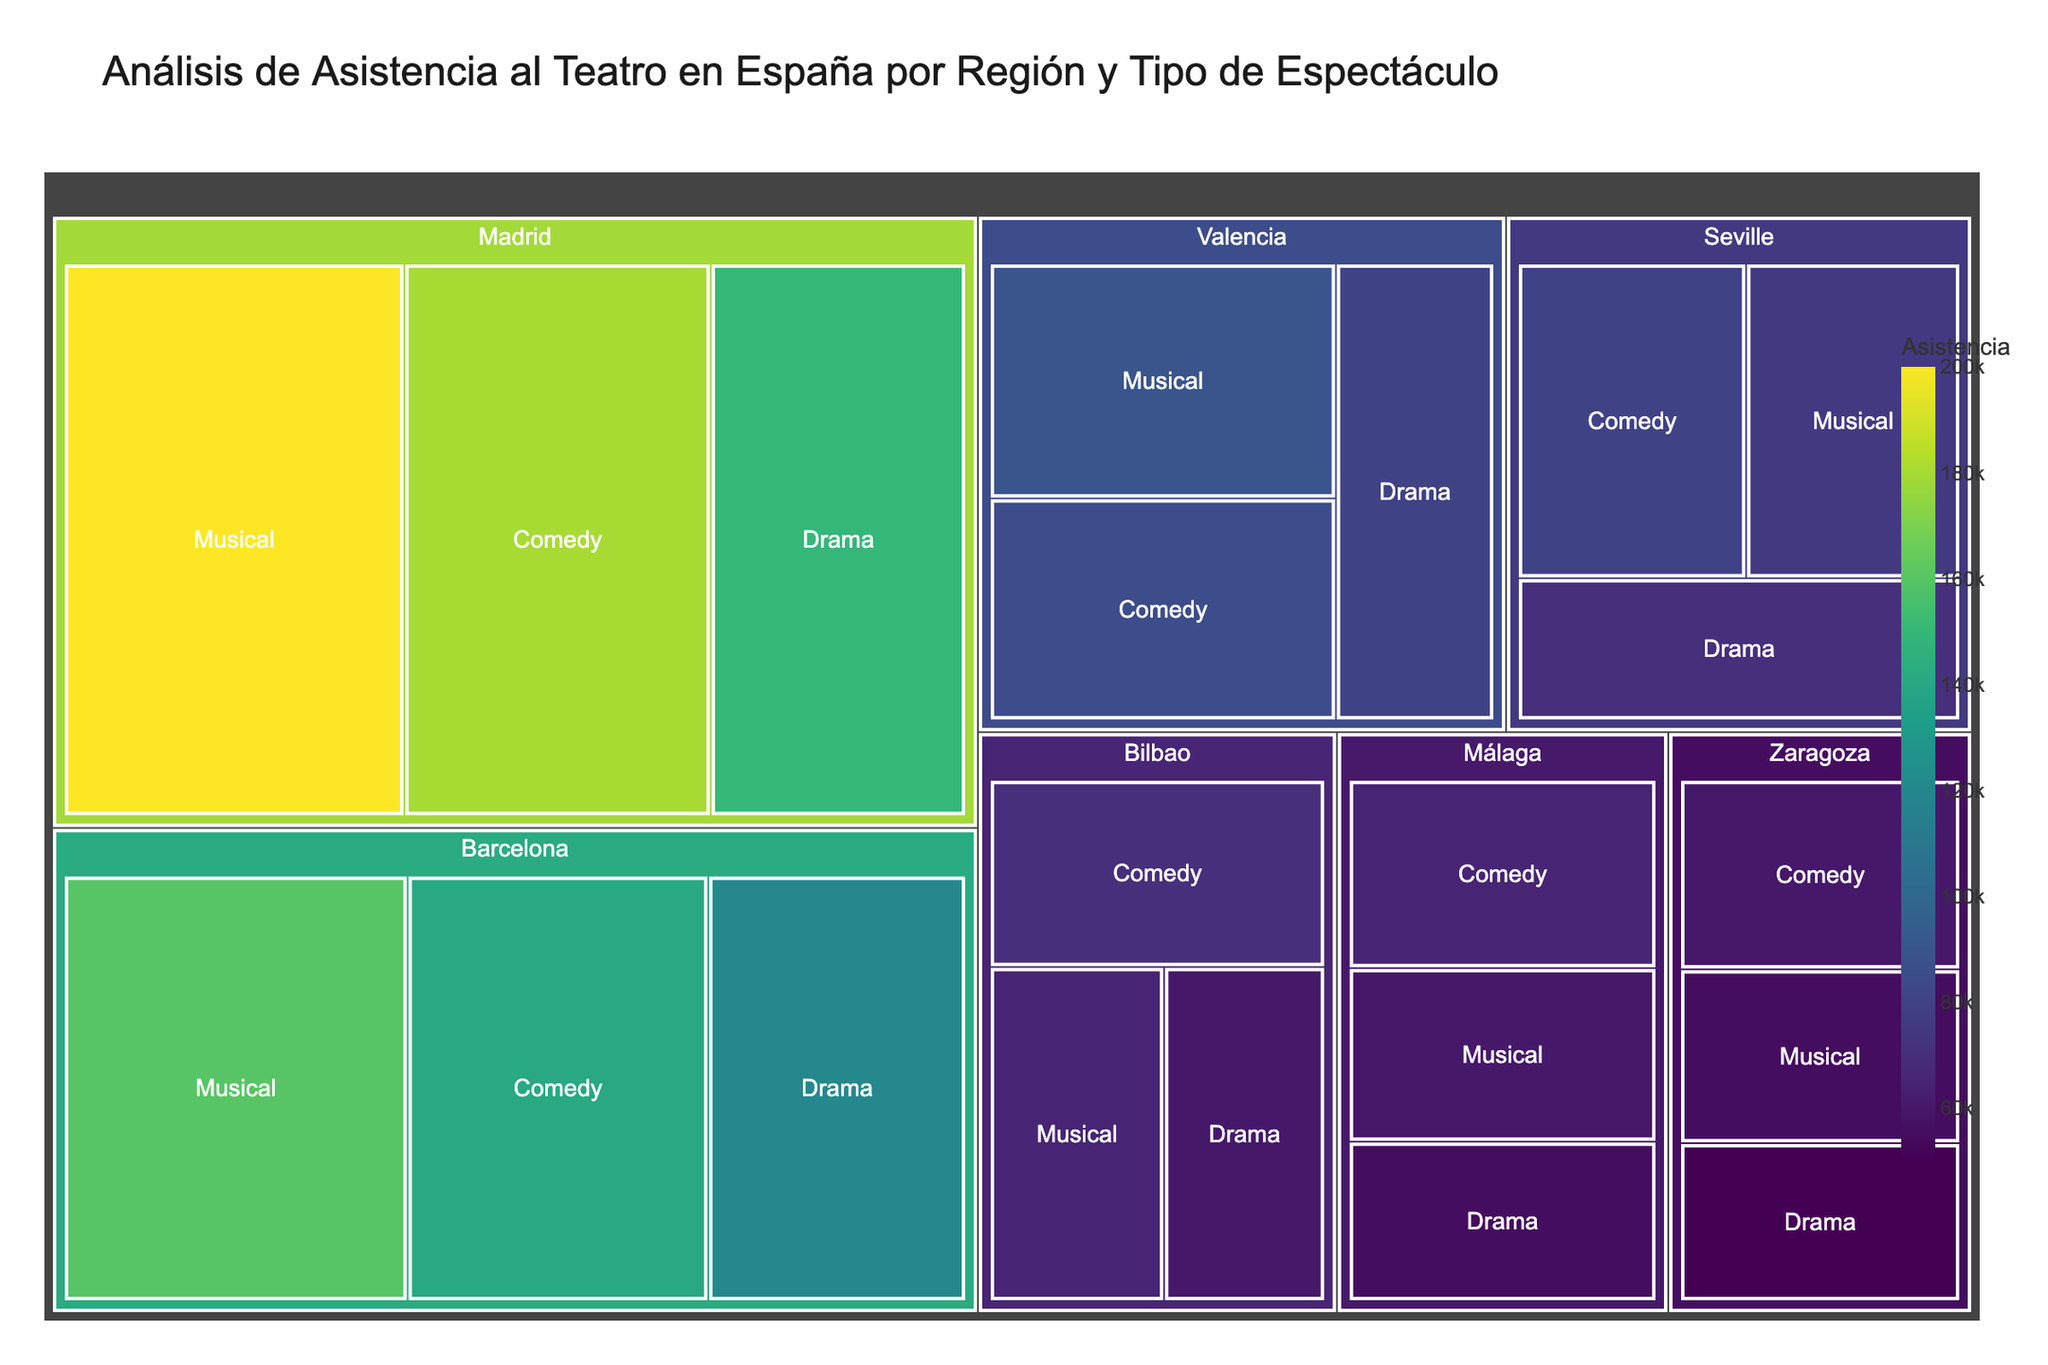¿Cuál es la asistencia total para la región de Madrid? Se pueden sumar los valores de asistencia para las tres categorías de rendimiento (Drama, Musical, Comedia) en Madrid: 150,000 + 200,000 + 180,000.
Answer: 530,000 ¿Cuál es la región con la menor asistencia en general? Sumar los valores de asistencia para cada región: Madrid, Barcelona, Valencia, Sevilla, Bilbao, Málaga, Zaragoza, y comparar estos totales. Málaga tiene la menor asistencia total.
Answer: Málaga ¿Qué tipo de rendimiento tiene la mayor asistencia en Barcelona? Comparar los valores de asistencia de los tipos de rendimiento en Barcelona: Drama (120,000), Musical (160,000), Comedia (140,000). Musical tiene la mayor asistencia.
Answer: Musical ¿Cómo se comparan las asistencias de Comedia entre Bilbao y Sevilla? Observar las asistencias de Comedia para Bilbao (70,000) y Sevilla (80,000) y compararlas. La asistencia en Sevilla es mayor.
Answer: Sevilla ¿Cuál es la región con el mayor porcentaje de asistencia en la categoría de Drama? Comparar los valores de asistencia de Drama en cada región y calcular el porcentaje sobre el total de asistencia de cada región. Madrid tiene la mayor asistencia en Drama comparado con su total.
Answer: Madrid ¿Qué tipo de rendimiento tiene la menor asistencia total en España? Sumar las asistencias de todas las regiones para cada tipo de rendimiento y encontrar cuál tiene el menor total. Comedia (180,000 + 140,000 + 85,000 + 80,000 + 70,000 + 65,000 + 60,000).
Answer: Comedia ¿Cuál es la diferencia de asistencia entre la categoría de Musical en Madrid y Valencia? Restar los valores de asistencia de la categoría Musical en Madrid y Valencia: 200,000 - 90,000.
Answer: 110,000 ¿Cuál es la región con la mayor asistencia para la categoría de Musical? Comparar las asistencias de la categoría Musical en todas las regiones: Madrid (200,000), Barcelona (160,000), Valencia (90,000), Sevilla (75,000), Bilbao (65,000), Málaga (60,000), Zaragoza (55,000). Madrid tiene la mayor asistencia.
Answer: Madrid ¿Cómo se distribuye la asistencia en las categorías de rendimiento en Valencia? Observar los valores de asistencia en Valencia para Drama (80,000), Musical (90,000), Comedia (85,000). La asistencia es relativamente equilibrada con Musical ligeramente más alto.
Answer: Equilibrada con predomino en Musical 